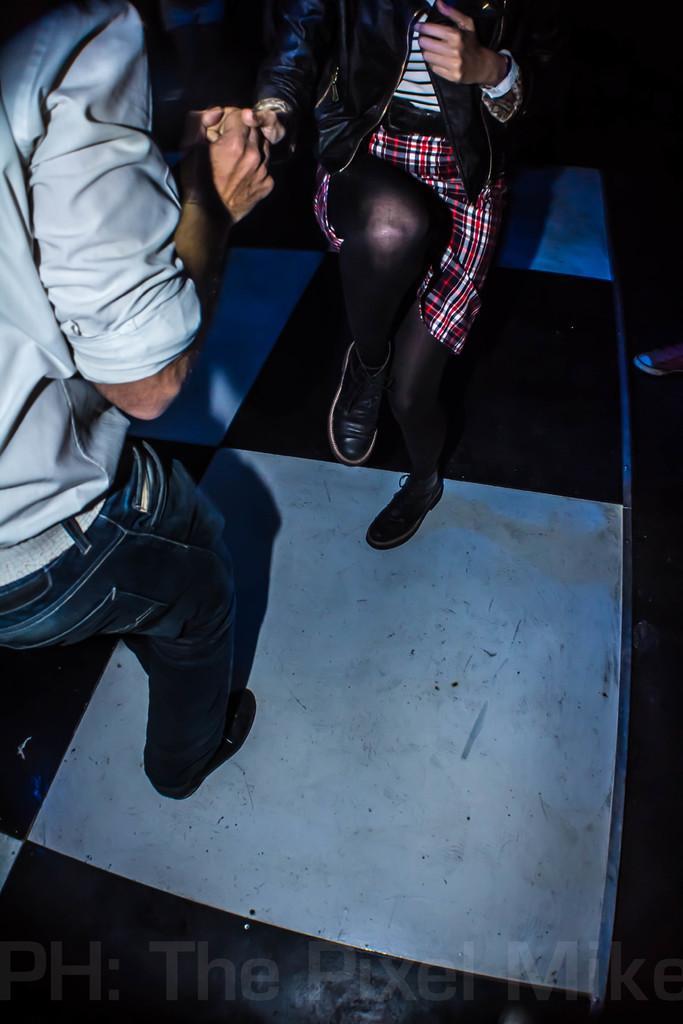Could you give a brief overview of what you see in this image? In this image we can see a man and a woman standing on the floor. On the bottom of the image we can see some text. 